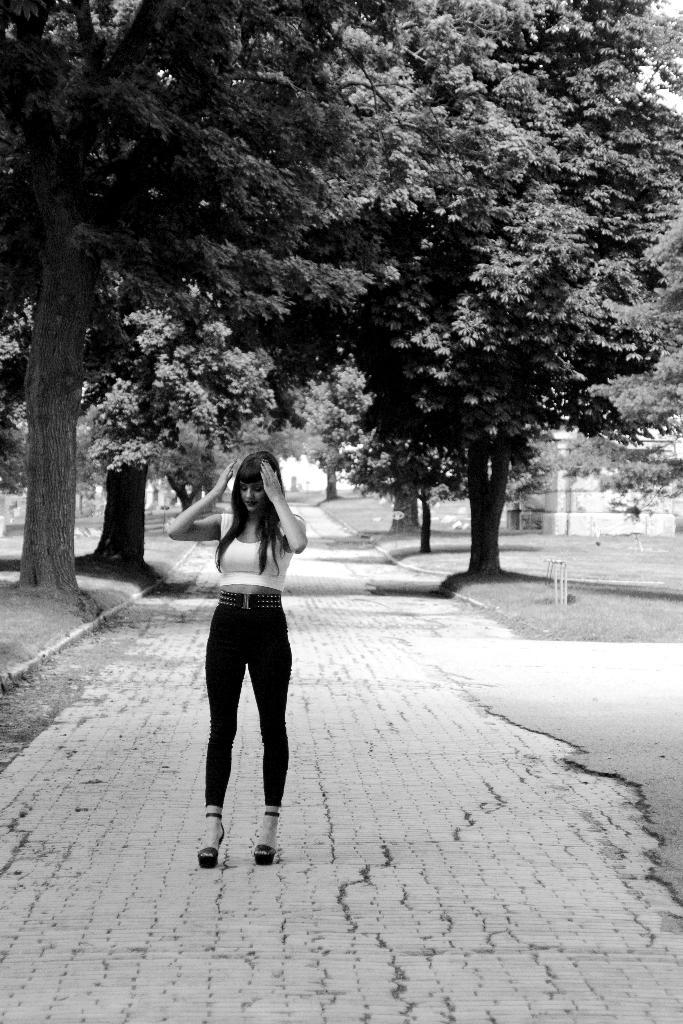Who is present in the image? There is a woman in the image. What is the woman doing in the image? The woman is standing on a path in the image. What is the color scheme of the image? The image is black and white. What can be seen in the background of the image? There are trees on either side of the path in the background. What type of fish is swimming in the image? There is no fish present in the image; it features a woman standing on a path in a black and white setting. 